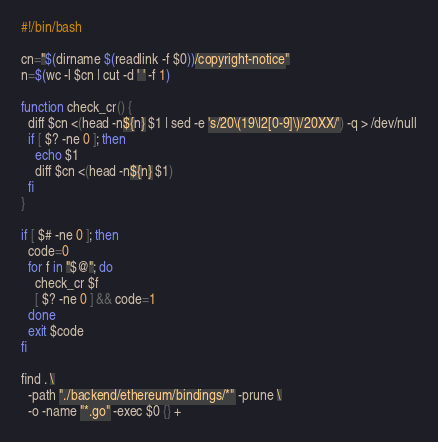<code> <loc_0><loc_0><loc_500><loc_500><_Bash_>#!/bin/bash

cn="$(dirname $(readlink -f $0))/copyright-notice"
n=$(wc -l $cn | cut -d ' ' -f 1)

function check_cr() {
  diff $cn <(head -n${n} $1 | sed -e 's/20\(19\|2[0-9]\)/20XX/') -q > /dev/null
  if [ $? -ne 0 ]; then
    echo $1
    diff $cn <(head -n${n} $1)
  fi
}

if [ $# -ne 0 ]; then
  code=0
  for f in "$@"; do
    check_cr $f
    [ $? -ne 0 ] && code=1
  done
  exit $code
fi

find . \
  -path "./backend/ethereum/bindings/*" -prune \
  -o -name "*.go" -exec $0 {} +
</code> 